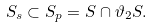Convert formula to latex. <formula><loc_0><loc_0><loc_500><loc_500>S _ { s } \subset S _ { p } = S \cap \vartheta _ { 2 } S .</formula> 